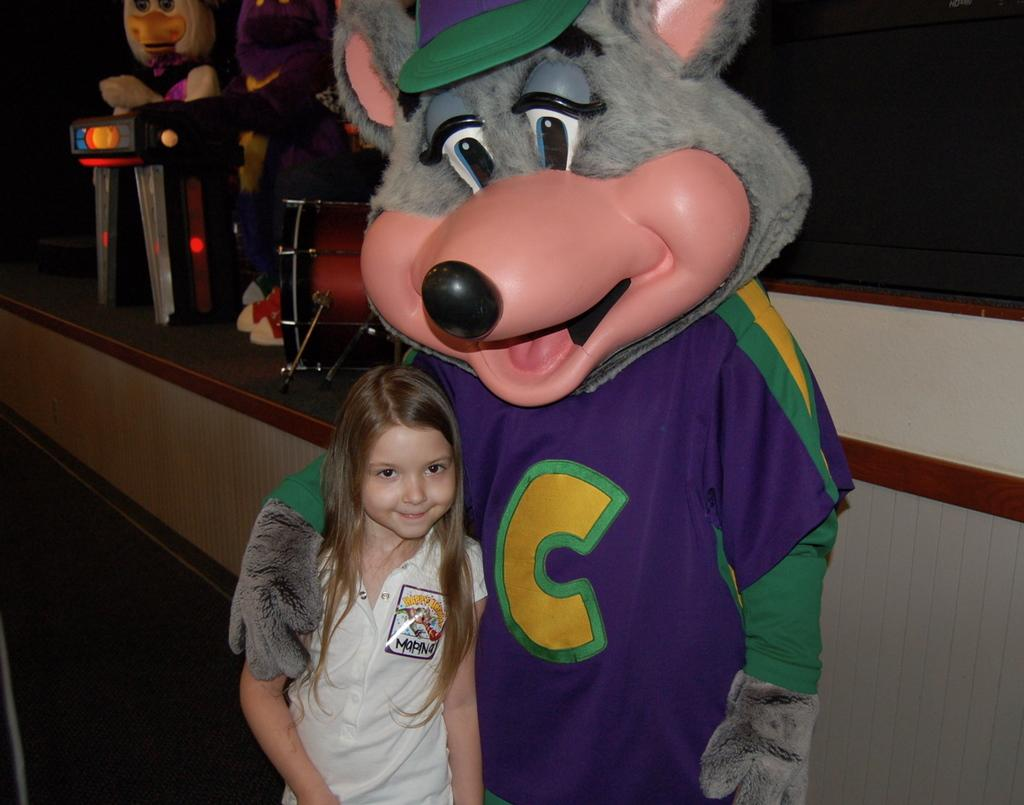What are the persons in the image wearing? The persons in the image are wearing costumes. Can you describe the girl in the image? There is a girl standing in the image. What can be seen in the background of the image? There is a stage in the background of the image. What is on the stage? Musical instruments are present on the stage. How many jellyfish can be seen swimming on the stage in the image? There are no jellyfish present in the image, and they cannot swim on a stage. 